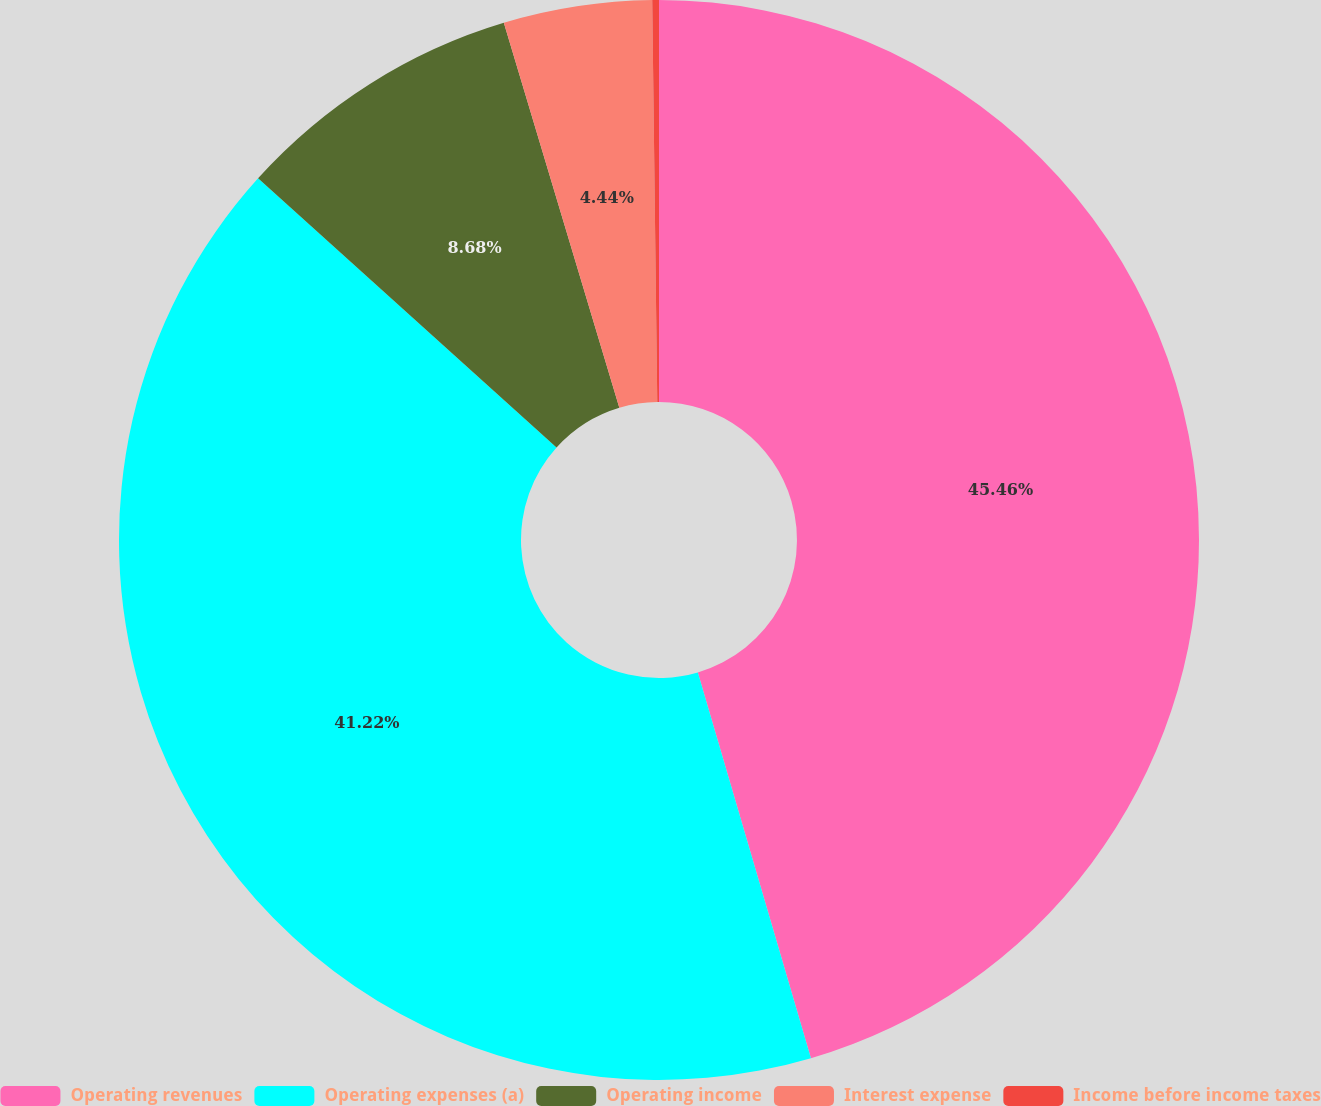<chart> <loc_0><loc_0><loc_500><loc_500><pie_chart><fcel>Operating revenues<fcel>Operating expenses (a)<fcel>Operating income<fcel>Interest expense<fcel>Income before income taxes<nl><fcel>45.47%<fcel>41.23%<fcel>8.68%<fcel>4.44%<fcel>0.2%<nl></chart> 